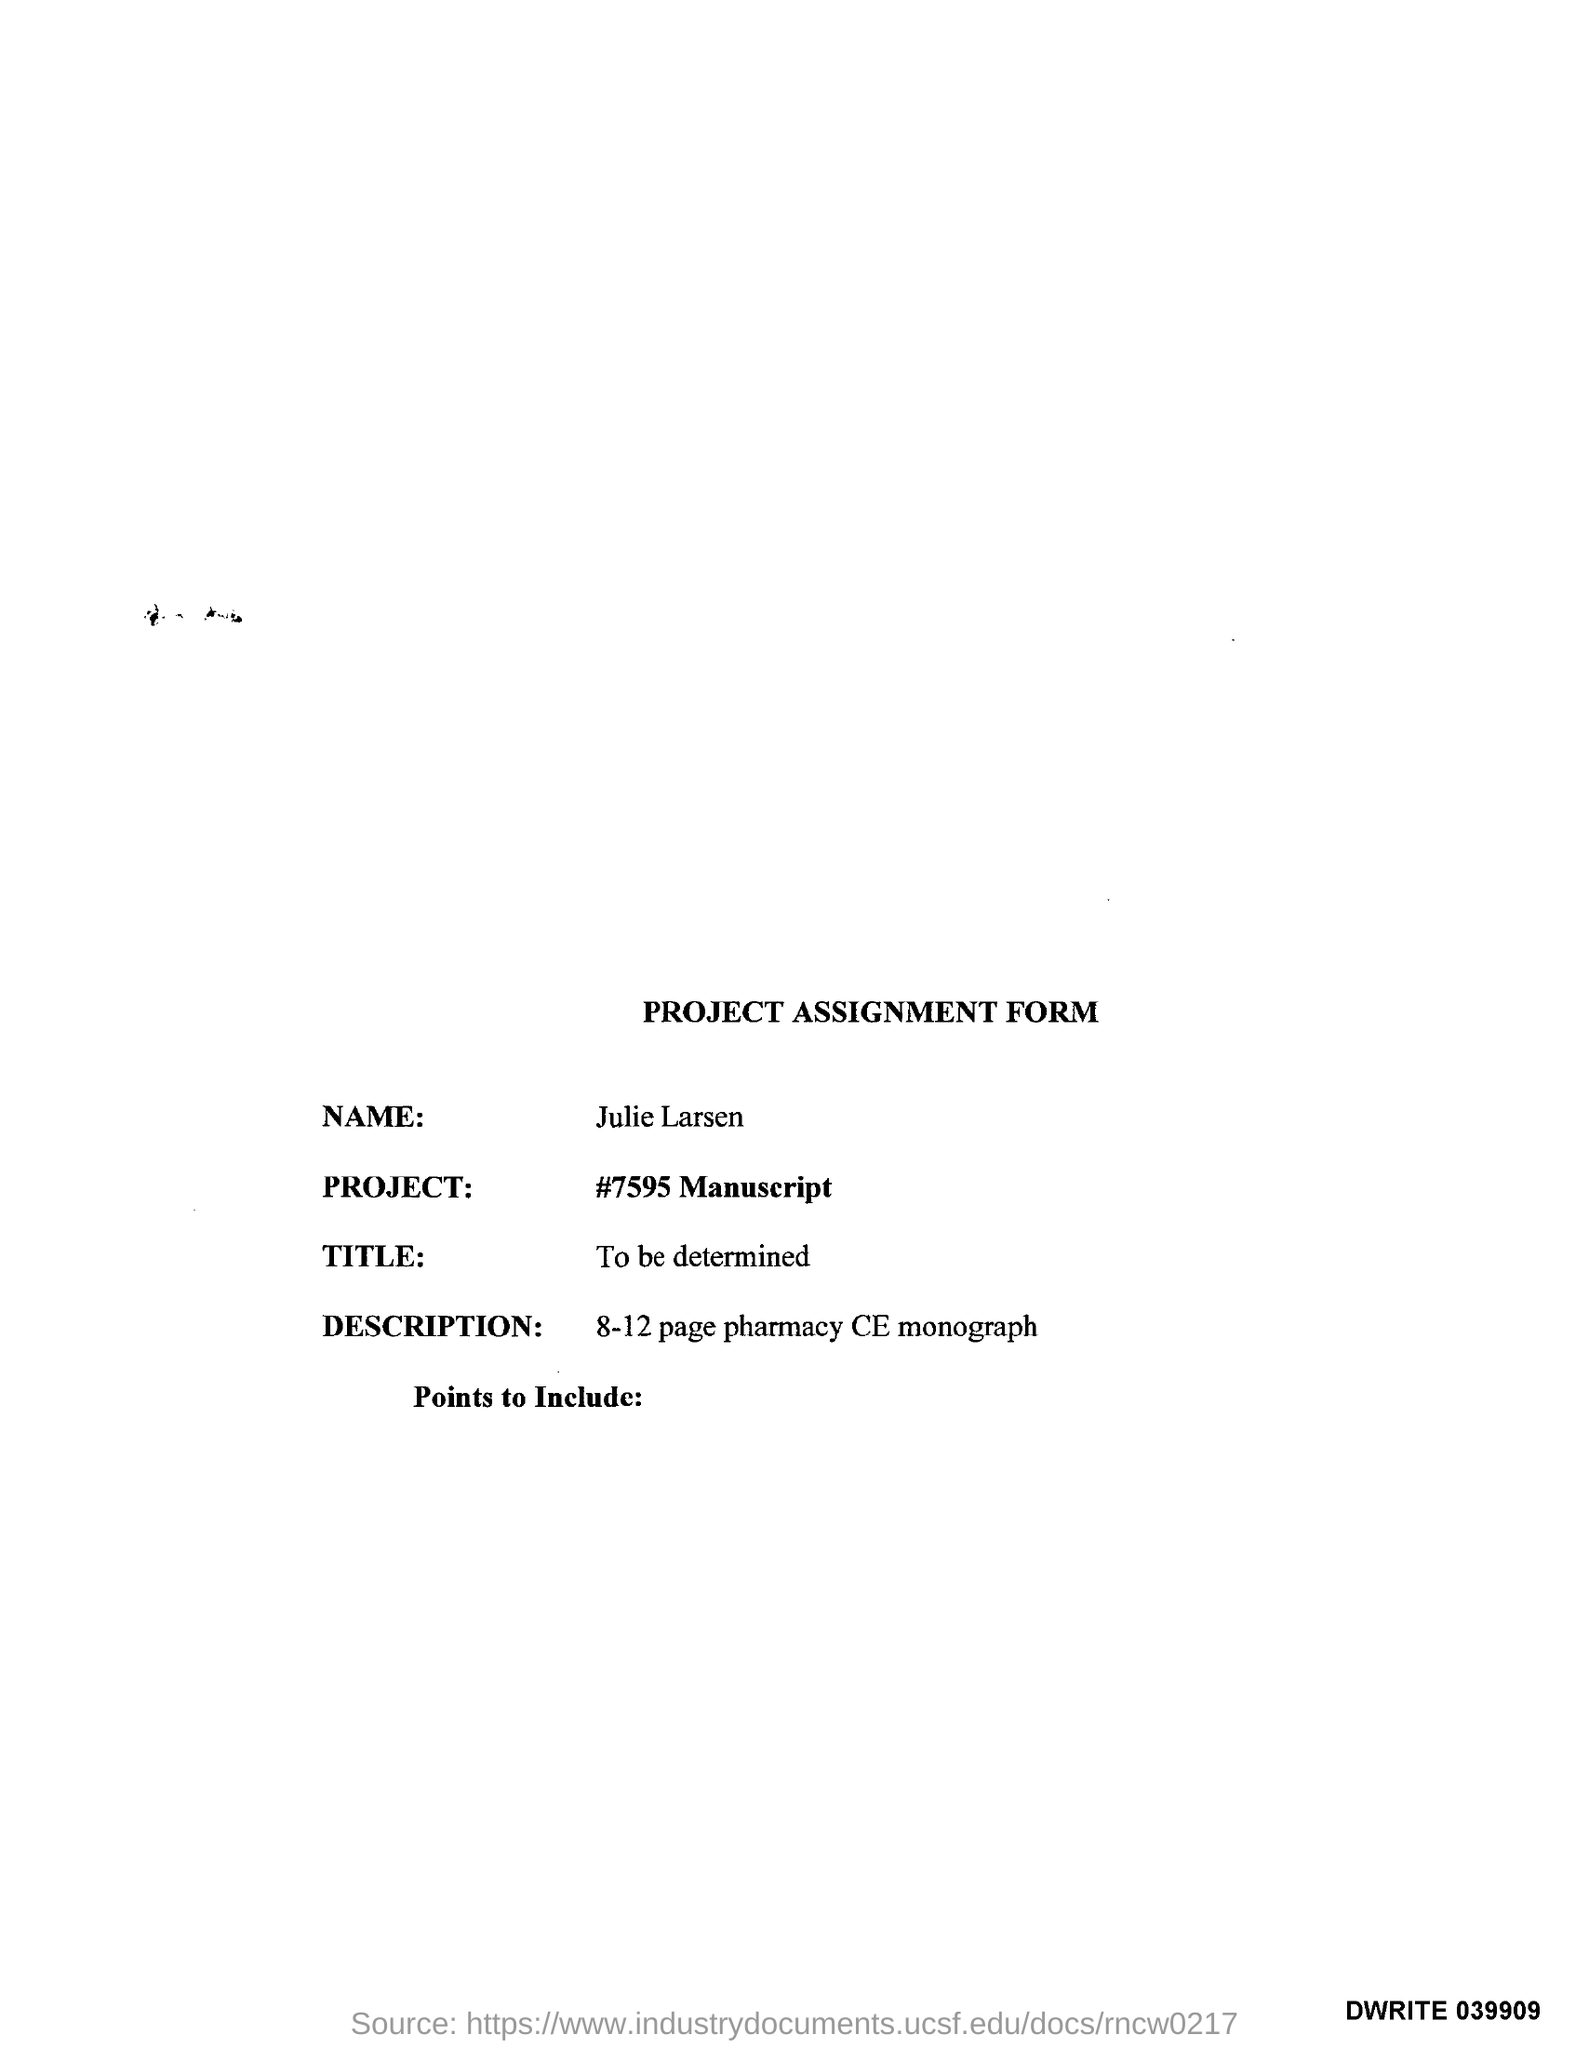Draw attention to some important aspects in this diagram. The name of the project is "Manuscript". The project was assigned by Julie Larsen. This is an 8-12 page pharmacy continuing education monograph with a description. 